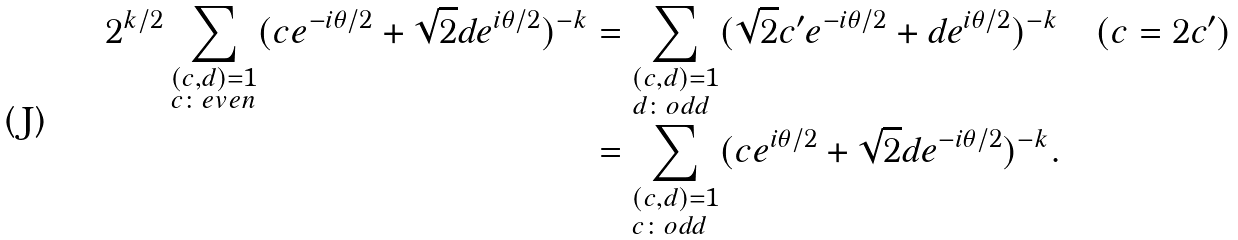Convert formula to latex. <formula><loc_0><loc_0><loc_500><loc_500>2 ^ { k / 2 } \sum _ { \begin{subarray} { c } ( c , d ) = 1 \\ c \colon e v e n \end{subarray} } ( c e ^ { - i \theta / 2 } + \sqrt { 2 } d e ^ { i \theta / 2 } ) ^ { - k } & = \sum _ { \begin{subarray} { c } ( c , d ) = 1 \\ d \colon o d d \end{subarray} } ( \sqrt { 2 } c ^ { \prime } e ^ { - i \theta / 2 } + d e ^ { i \theta / 2 } ) ^ { - k } \quad ( c = 2 c ^ { \prime } ) \\ & = \sum _ { \begin{subarray} { c } ( c , d ) = 1 \\ c \colon o d d \end{subarray} } ( c e ^ { i \theta / 2 } + \sqrt { 2 } d e ^ { - i \theta / 2 } ) ^ { - k } .</formula> 